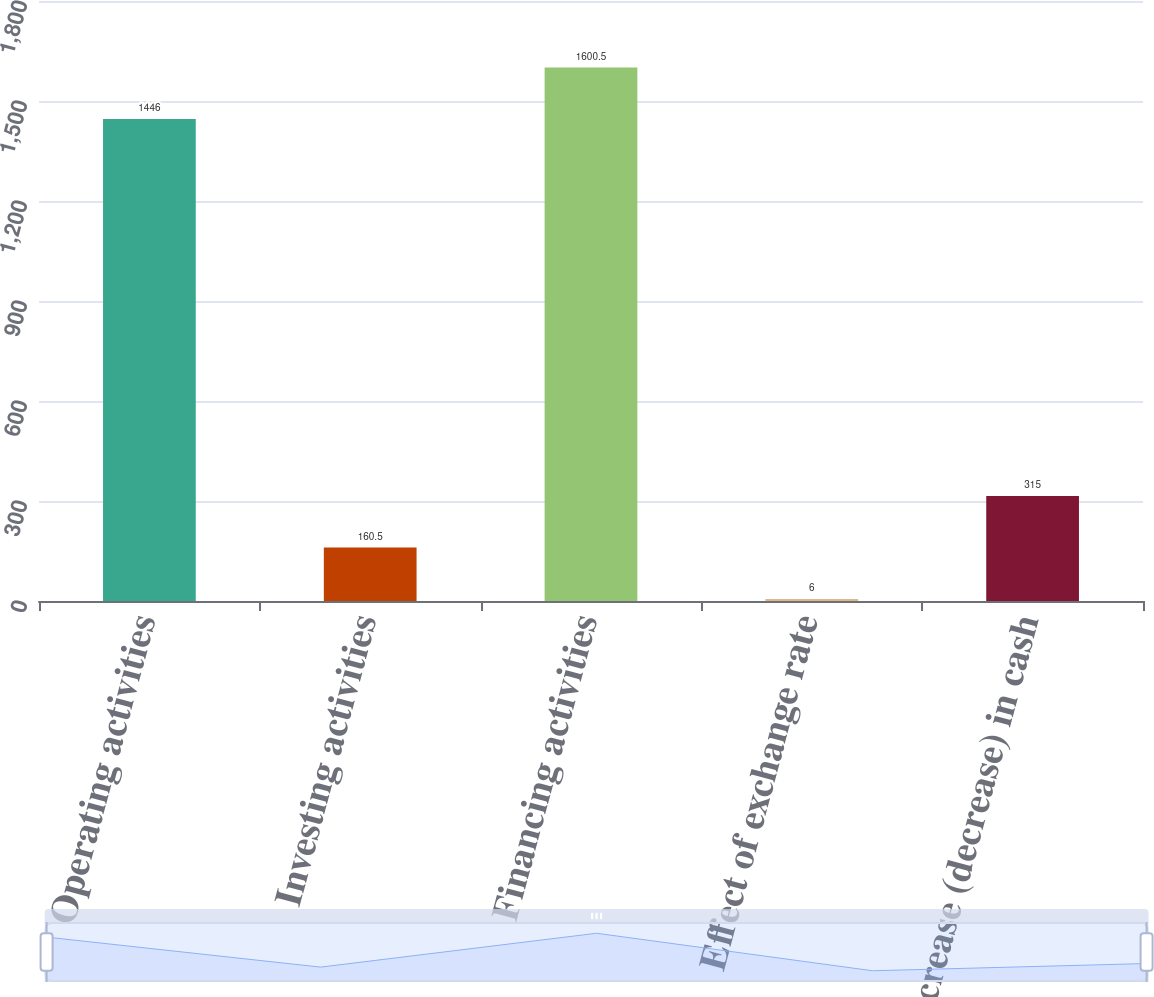<chart> <loc_0><loc_0><loc_500><loc_500><bar_chart><fcel>Operating activities<fcel>Investing activities<fcel>Financing activities<fcel>Effect of exchange rate<fcel>Increase (decrease) in cash<nl><fcel>1446<fcel>160.5<fcel>1600.5<fcel>6<fcel>315<nl></chart> 